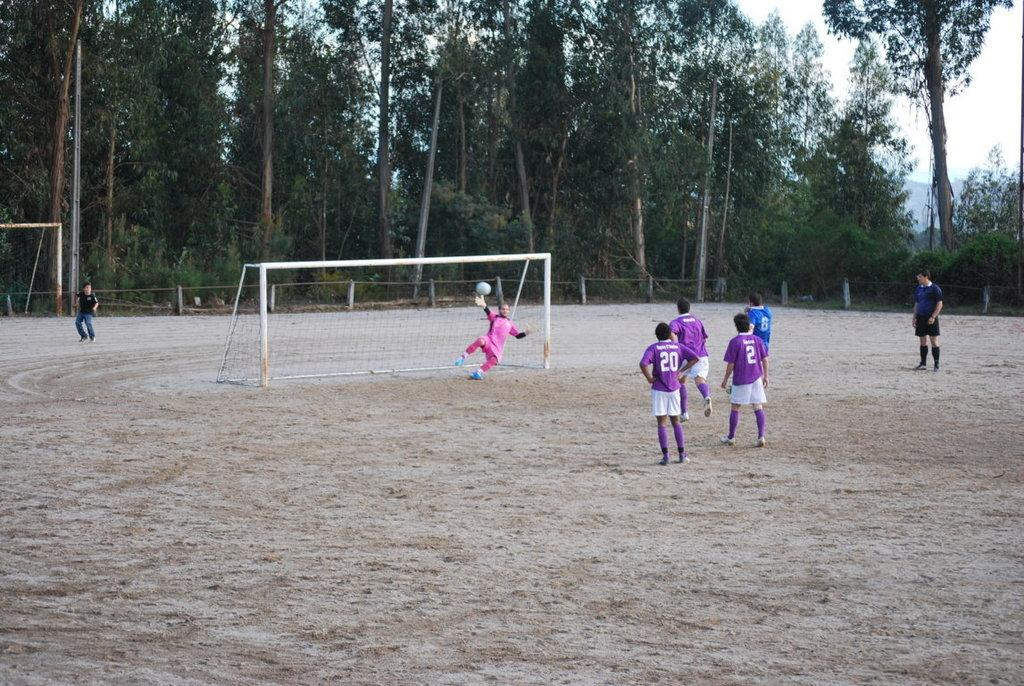<image>
Provide a brief description of the given image. Players 2 and 20 stand near each other watching the goalie. 